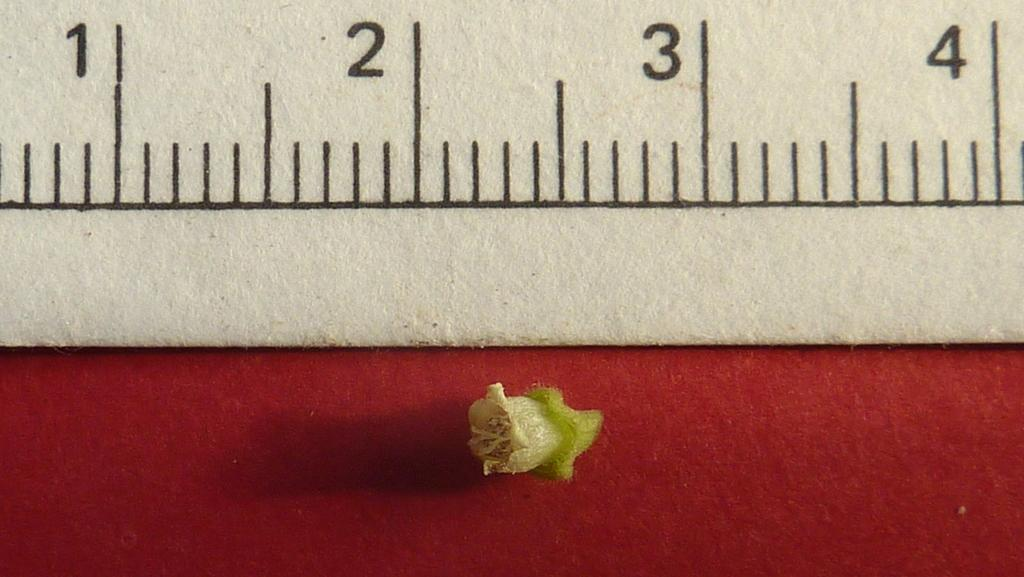<image>
Relay a brief, clear account of the picture shown. The flower on the red background measures less than 1/2 an inch. 